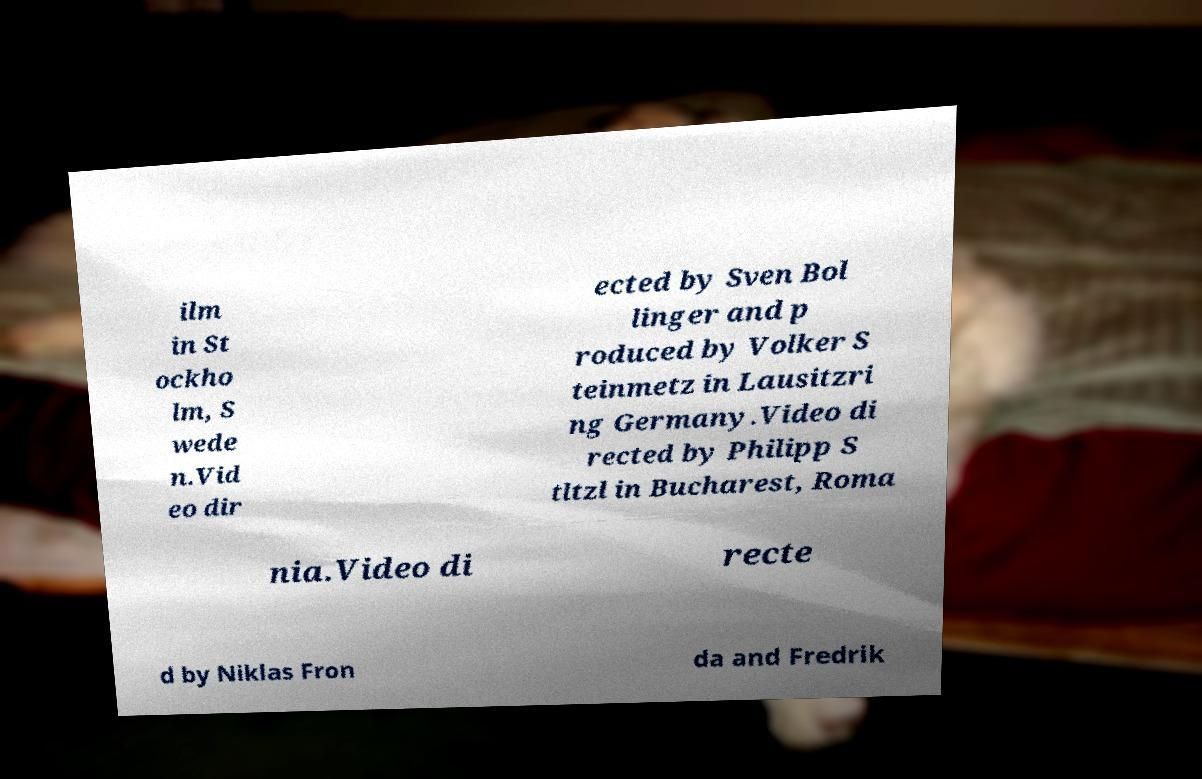Could you extract and type out the text from this image? ilm in St ockho lm, S wede n.Vid eo dir ected by Sven Bol linger and p roduced by Volker S teinmetz in Lausitzri ng Germany.Video di rected by Philipp S tltzl in Bucharest, Roma nia.Video di recte d by Niklas Fron da and Fredrik 